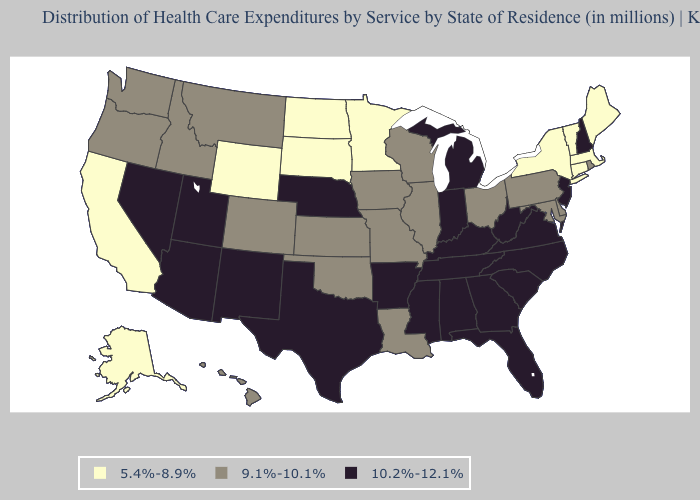Does Florida have the same value as Wyoming?
Give a very brief answer. No. Does Missouri have a higher value than Connecticut?
Quick response, please. Yes. Among the states that border Iowa , which have the highest value?
Short answer required. Nebraska. Does Idaho have a higher value than South Dakota?
Answer briefly. Yes. Among the states that border Massachusetts , does Vermont have the highest value?
Write a very short answer. No. What is the value of Alabama?
Answer briefly. 10.2%-12.1%. What is the value of Idaho?
Give a very brief answer. 9.1%-10.1%. What is the value of Vermont?
Keep it brief. 5.4%-8.9%. Does Indiana have the highest value in the MidWest?
Answer briefly. Yes. Does Wisconsin have a lower value than Nebraska?
Write a very short answer. Yes. What is the lowest value in the USA?
Answer briefly. 5.4%-8.9%. Does the first symbol in the legend represent the smallest category?
Write a very short answer. Yes. Does Missouri have a higher value than Rhode Island?
Keep it brief. No. What is the value of Nevada?
Short answer required. 10.2%-12.1%. 